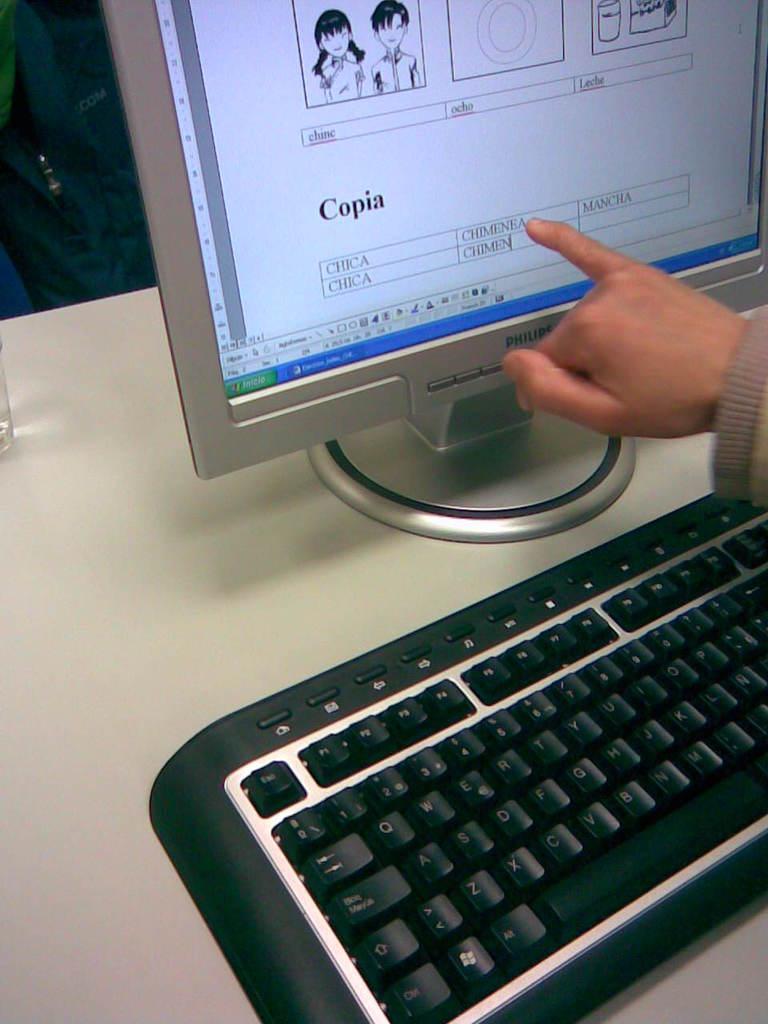What word is written in bold black letters on the screen?
Your answer should be compact. Copia. This is computer?
Your response must be concise. Answering does not require reading text in the image. 